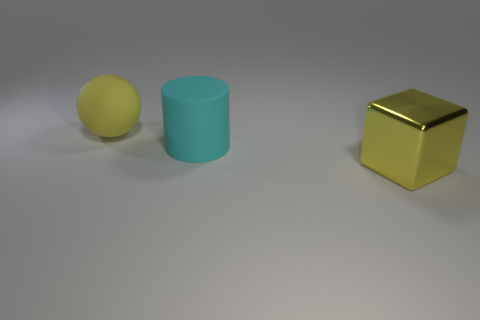Add 1 large green rubber cylinders. How many objects exist? 4 Subtract 1 spheres. How many spheres are left? 0 Subtract 0 gray cylinders. How many objects are left? 3 Subtract all cylinders. How many objects are left? 2 Subtract all green cubes. Subtract all blue cylinders. How many cubes are left? 1 Subtract all green balls. How many gray cylinders are left? 0 Subtract all tiny metallic cubes. Subtract all yellow things. How many objects are left? 1 Add 1 cyan rubber cylinders. How many cyan rubber cylinders are left? 2 Add 3 big yellow matte balls. How many big yellow matte balls exist? 4 